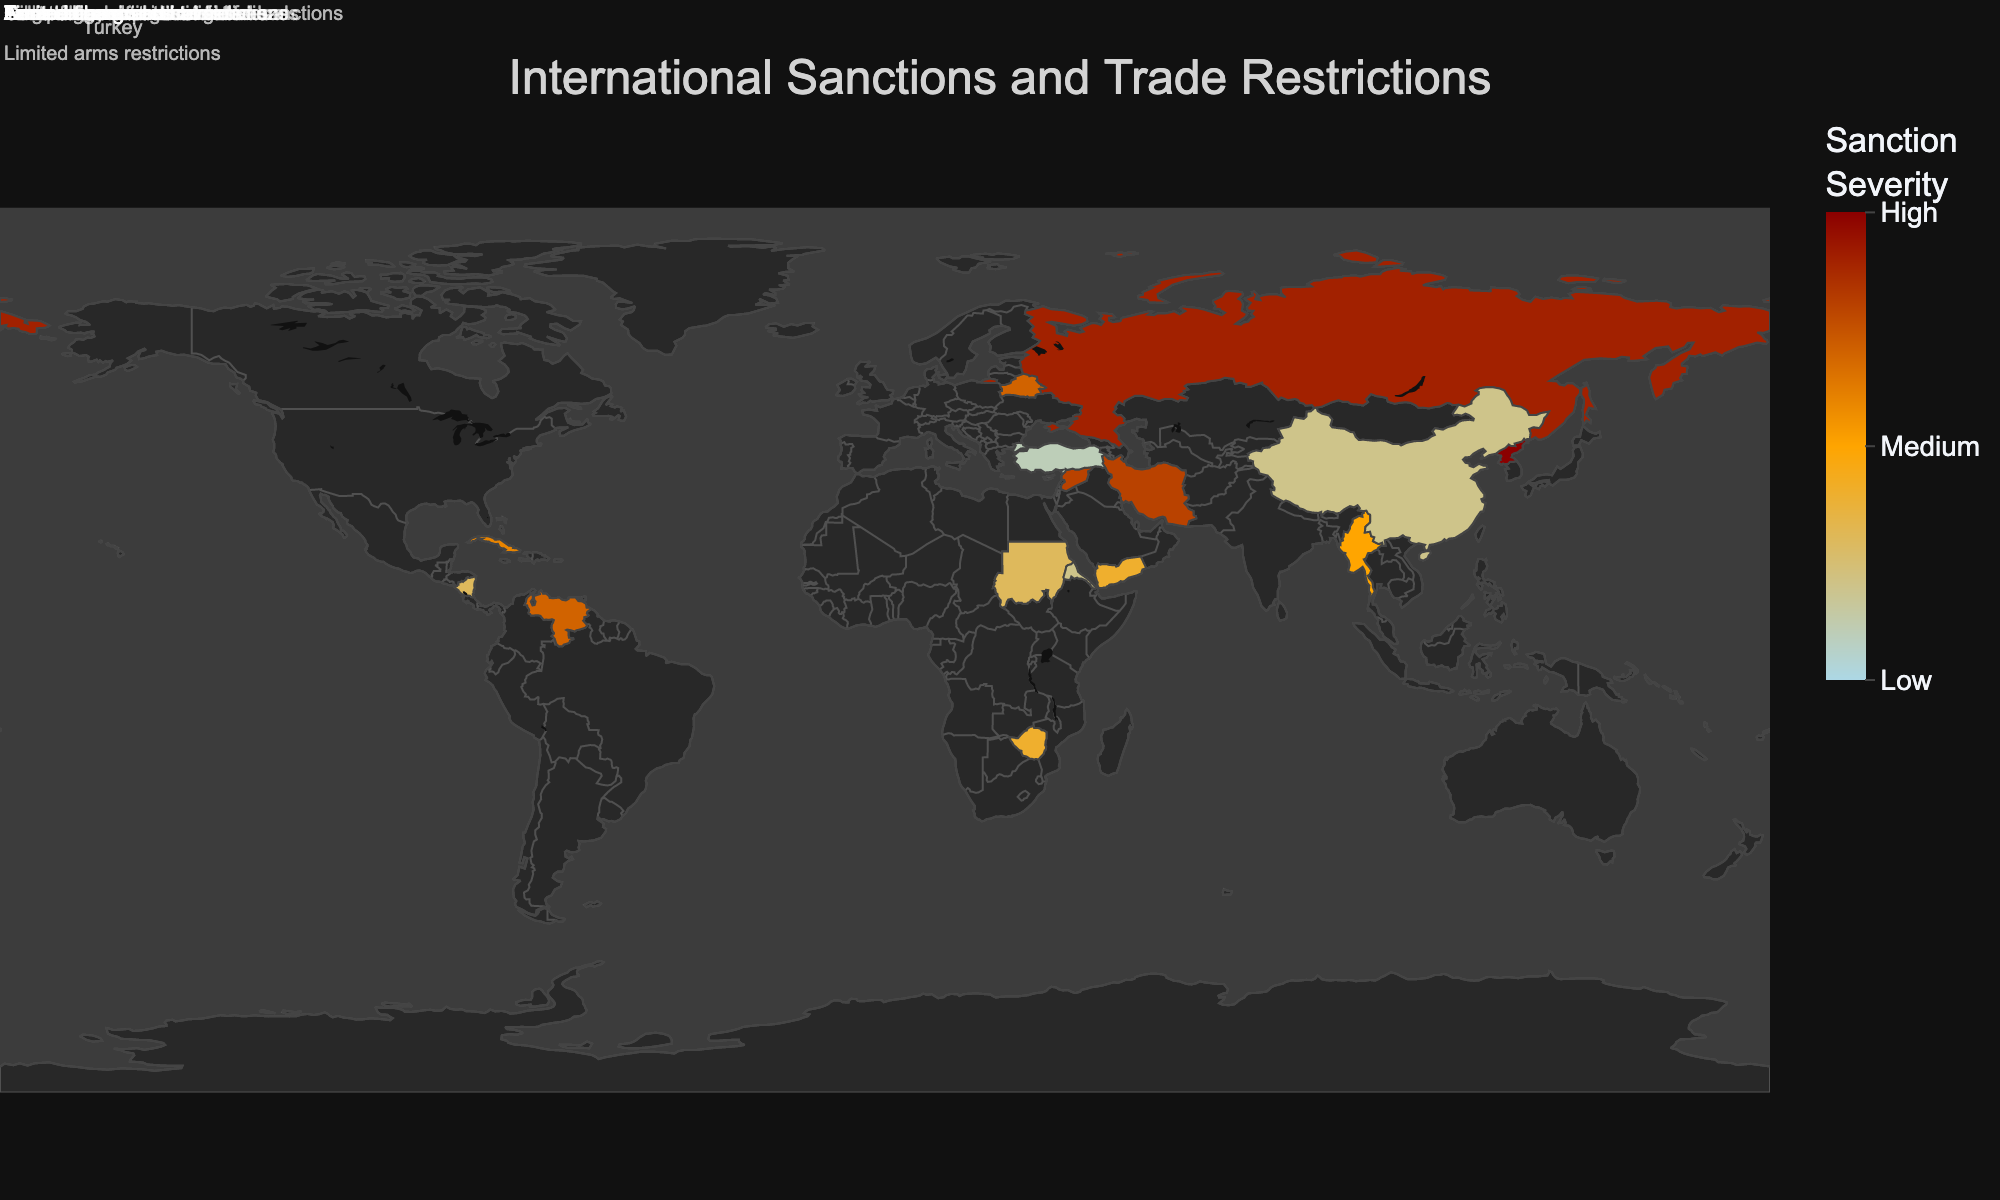what is the title of the plot? The title of the plot is displayed at the top center of the figure, in large light-grey text.
Answer: International Sanctions and Trade Restrictions which country has the highest sanction severity? The highest severity is indicated by the darkest red color and the number "10". North Korea shows up as the darkest shade and has a severity of 10.
Answer: North Korea how many countries have a sanction severity of 4 or above? The colors representing the sanction severity range from light blue (low severity) to dark red (high severity). Countries with a sanction severity of 4 or more will be in shades ranging from orange to dark red. There are eight such countries: Russia, Iran, North Korea, Venezuela, Syria, Cuba, Belarus, Yemen.
Answer: 8 compare the types of trade restrictions imposed on Russia and Iran. Hover over the countries Russia and Iran which are colored according to their sanction severity. The hover text will show that Russia has a "Full trade embargo" whereas Iran has "Oil and gas restrictions".
Answer: Russia: Full trade embargo, Iran: Oil and gas restrictions which country faces the most severe trade restriction related to technology? Identify the trade restriction types which contain the keyword "technology". By examining the visual and hover data, China has a  technology-related trade restriction but with a low severity of 2, so it’s not the most severe.
Answer: China what is the median value of sanction severity across all countries? List all the sanction severities: 9, 8, 10, 7, 8, 6, 7, 5, 4, 3, 2, 1, 3, 2, 4. Order them: 1, 2, 2, 3, 3, 4, 4, 5, 6, 7, 7, 8, 8, 9, 10. The middle value (or average of the two middle values) in a list of 15 numbers is the 8th number: 5.
Answer: 5 how does the sanction severity for Venezuela compare with that of Syria? Look at the color gradients and hover data for Venezuela and Syria. Venezuela has a severity of 7, whereas Syria has a severity of 8.
Answer: Syria's severity is greater what type of trade restriction is imposed on Cuba? Hover over the country Cuba will show the type of trade restriction. Cuba has "Limited trade restrictions".
Answer: Limited trade restrictions are there more countries with severity above 5, or at 5 and below? Count the number of countries with severity more than 5 and compare it with those with 5 or less. Greater than 5: Russia, Iran, North Korea, Venezuela, Syria, Cuba, Belarus (7 countries). 5 or below: Myanmar, Zimbabwe, Sudan, China, Turkey, Nicaragua, Eritrea, Yemen (8 countries).
Answer: More countries with severity 5 and below 